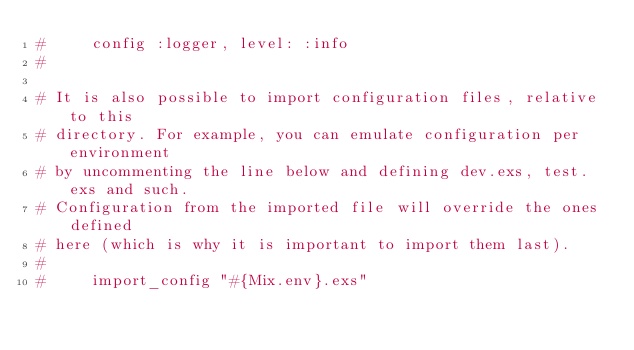<code> <loc_0><loc_0><loc_500><loc_500><_Elixir_>#     config :logger, level: :info
#

# It is also possible to import configuration files, relative to this
# directory. For example, you can emulate configuration per environment
# by uncommenting the line below and defining dev.exs, test.exs and such.
# Configuration from the imported file will override the ones defined
# here (which is why it is important to import them last).
#
#     import_config "#{Mix.env}.exs"
</code> 